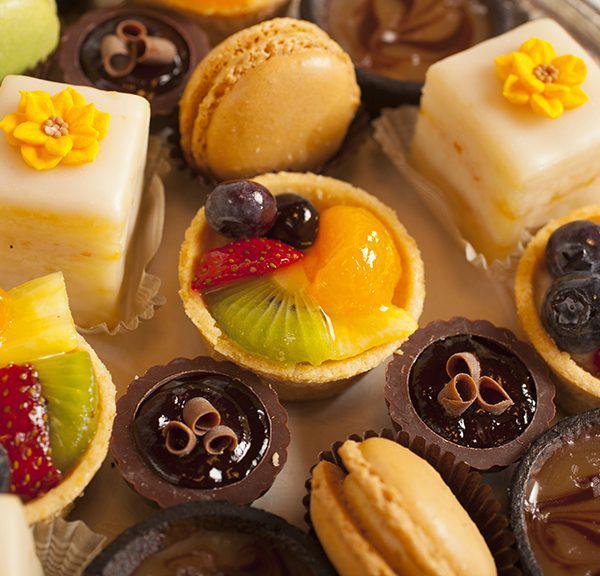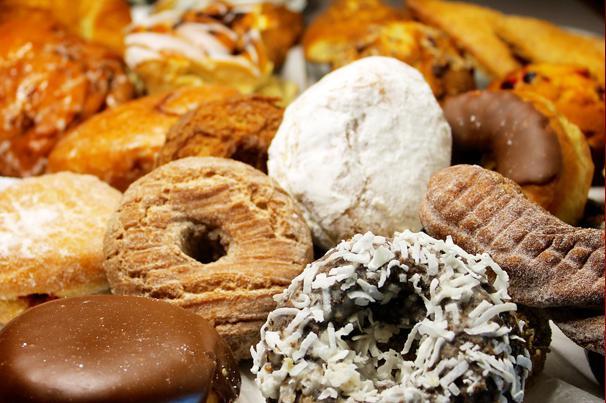The first image is the image on the left, the second image is the image on the right. Evaluate the accuracy of this statement regarding the images: "There are strawberries on top of some of the desserts.". Is it true? Answer yes or no. Yes. The first image is the image on the left, the second image is the image on the right. Analyze the images presented: Is the assertion "The left image shows individual round desserts in rows on a tray, and at least one row of desserts have red berries on top." valid? Answer yes or no. No. 